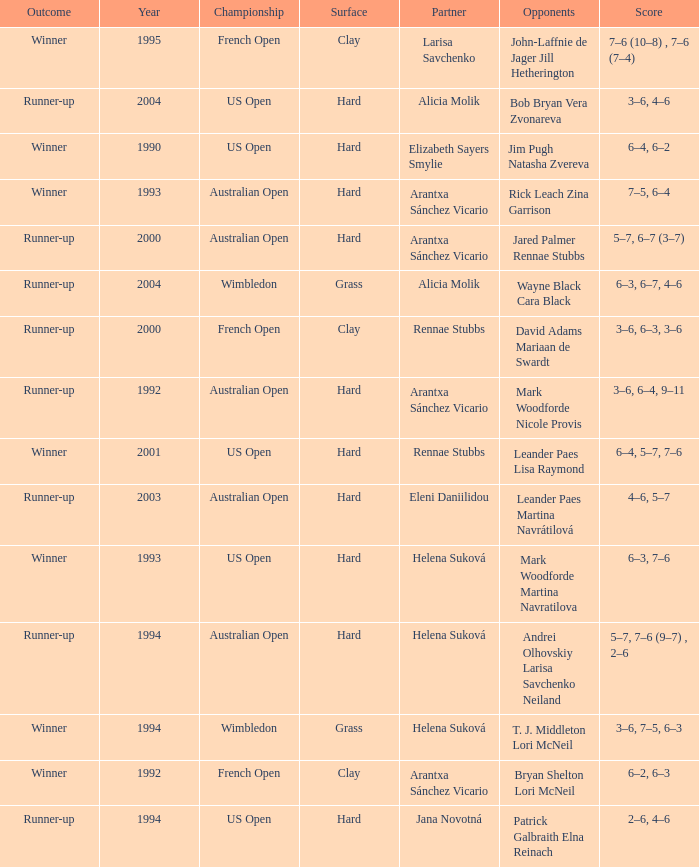Which Score has smaller than 1994, and a Partner of elizabeth sayers smylie? 6–4, 6–2. Give me the full table as a dictionary. {'header': ['Outcome', 'Year', 'Championship', 'Surface', 'Partner', 'Opponents', 'Score'], 'rows': [['Winner', '1995', 'French Open', 'Clay', 'Larisa Savchenko', 'John-Laffnie de Jager Jill Hetherington', '7–6 (10–8) , 7–6 (7–4)'], ['Runner-up', '2004', 'US Open', 'Hard', 'Alicia Molik', 'Bob Bryan Vera Zvonareva', '3–6, 4–6'], ['Winner', '1990', 'US Open', 'Hard', 'Elizabeth Sayers Smylie', 'Jim Pugh Natasha Zvereva', '6–4, 6–2'], ['Winner', '1993', 'Australian Open', 'Hard', 'Arantxa Sánchez Vicario', 'Rick Leach Zina Garrison', '7–5, 6–4'], ['Runner-up', '2000', 'Australian Open', 'Hard', 'Arantxa Sánchez Vicario', 'Jared Palmer Rennae Stubbs', '5–7, 6–7 (3–7)'], ['Runner-up', '2004', 'Wimbledon', 'Grass', 'Alicia Molik', 'Wayne Black Cara Black', '6–3, 6–7, 4–6'], ['Runner-up', '2000', 'French Open', 'Clay', 'Rennae Stubbs', 'David Adams Mariaan de Swardt', '3–6, 6–3, 3–6'], ['Runner-up', '1992', 'Australian Open', 'Hard', 'Arantxa Sánchez Vicario', 'Mark Woodforde Nicole Provis', '3–6, 6–4, 9–11'], ['Winner', '2001', 'US Open', 'Hard', 'Rennae Stubbs', 'Leander Paes Lisa Raymond', '6–4, 5–7, 7–6'], ['Runner-up', '2003', 'Australian Open', 'Hard', 'Eleni Daniilidou', 'Leander Paes Martina Navrátilová', '4–6, 5–7'], ['Winner', '1993', 'US Open', 'Hard', 'Helena Suková', 'Mark Woodforde Martina Navratilova', '6–3, 7–6'], ['Runner-up', '1994', 'Australian Open', 'Hard', 'Helena Suková', 'Andrei Olhovskiy Larisa Savchenko Neiland', '5–7, 7–6 (9–7) , 2–6'], ['Winner', '1994', 'Wimbledon', 'Grass', 'Helena Suková', 'T. J. Middleton Lori McNeil', '3–6, 7–5, 6–3'], ['Winner', '1992', 'French Open', 'Clay', 'Arantxa Sánchez Vicario', 'Bryan Shelton Lori McNeil', '6–2, 6–3'], ['Runner-up', '1994', 'US Open', 'Hard', 'Jana Novotná', 'Patrick Galbraith Elna Reinach', '2–6, 4–6']]} 